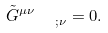<formula> <loc_0><loc_0><loc_500><loc_500>\tilde { G } _ { \quad ; \nu } ^ { \mu \nu } = 0 .</formula> 